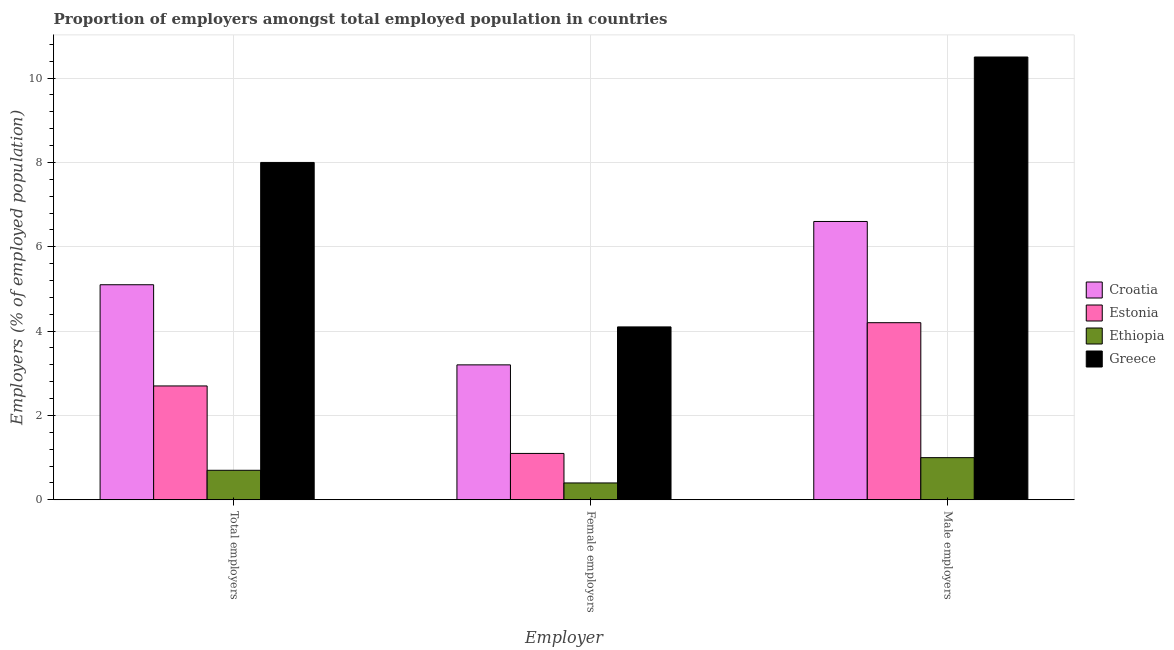How many bars are there on the 1st tick from the right?
Your answer should be very brief. 4. What is the label of the 2nd group of bars from the left?
Make the answer very short. Female employers. What is the percentage of female employers in Ethiopia?
Give a very brief answer. 0.4. Across all countries, what is the maximum percentage of female employers?
Your answer should be compact. 4.1. In which country was the percentage of male employers maximum?
Your response must be concise. Greece. In which country was the percentage of male employers minimum?
Offer a terse response. Ethiopia. What is the total percentage of total employers in the graph?
Your answer should be very brief. 16.5. What is the difference between the percentage of total employers in Greece and that in Estonia?
Make the answer very short. 5.3. What is the difference between the percentage of female employers in Estonia and the percentage of total employers in Greece?
Your response must be concise. -6.9. What is the average percentage of total employers per country?
Offer a very short reply. 4.12. What is the difference between the percentage of female employers and percentage of male employers in Estonia?
Give a very brief answer. -3.1. What is the ratio of the percentage of male employers in Croatia to that in Greece?
Provide a short and direct response. 0.63. Is the percentage of total employers in Greece less than that in Estonia?
Ensure brevity in your answer.  No. What is the difference between the highest and the second highest percentage of female employers?
Keep it short and to the point. 0.9. What is the difference between the highest and the lowest percentage of total employers?
Offer a very short reply. 7.3. In how many countries, is the percentage of male employers greater than the average percentage of male employers taken over all countries?
Your answer should be very brief. 2. What does the 3rd bar from the left in Female employers represents?
Your answer should be compact. Ethiopia. What does the 4th bar from the right in Male employers represents?
Offer a terse response. Croatia. Is it the case that in every country, the sum of the percentage of total employers and percentage of female employers is greater than the percentage of male employers?
Offer a terse response. No. What is the difference between two consecutive major ticks on the Y-axis?
Ensure brevity in your answer.  2. How are the legend labels stacked?
Your response must be concise. Vertical. What is the title of the graph?
Provide a succinct answer. Proportion of employers amongst total employed population in countries. Does "Ethiopia" appear as one of the legend labels in the graph?
Keep it short and to the point. Yes. What is the label or title of the X-axis?
Your response must be concise. Employer. What is the label or title of the Y-axis?
Make the answer very short. Employers (% of employed population). What is the Employers (% of employed population) in Croatia in Total employers?
Provide a short and direct response. 5.1. What is the Employers (% of employed population) of Estonia in Total employers?
Provide a short and direct response. 2.7. What is the Employers (% of employed population) of Ethiopia in Total employers?
Provide a short and direct response. 0.7. What is the Employers (% of employed population) in Croatia in Female employers?
Provide a short and direct response. 3.2. What is the Employers (% of employed population) in Estonia in Female employers?
Keep it short and to the point. 1.1. What is the Employers (% of employed population) in Ethiopia in Female employers?
Give a very brief answer. 0.4. What is the Employers (% of employed population) in Greece in Female employers?
Keep it short and to the point. 4.1. What is the Employers (% of employed population) of Croatia in Male employers?
Your response must be concise. 6.6. What is the Employers (% of employed population) in Estonia in Male employers?
Give a very brief answer. 4.2. What is the Employers (% of employed population) in Ethiopia in Male employers?
Make the answer very short. 1. What is the Employers (% of employed population) in Greece in Male employers?
Offer a very short reply. 10.5. Across all Employer, what is the maximum Employers (% of employed population) of Croatia?
Offer a terse response. 6.6. Across all Employer, what is the maximum Employers (% of employed population) of Estonia?
Your answer should be compact. 4.2. Across all Employer, what is the minimum Employers (% of employed population) in Croatia?
Give a very brief answer. 3.2. Across all Employer, what is the minimum Employers (% of employed population) of Estonia?
Provide a short and direct response. 1.1. Across all Employer, what is the minimum Employers (% of employed population) of Ethiopia?
Give a very brief answer. 0.4. Across all Employer, what is the minimum Employers (% of employed population) in Greece?
Provide a short and direct response. 4.1. What is the total Employers (% of employed population) of Croatia in the graph?
Make the answer very short. 14.9. What is the total Employers (% of employed population) in Estonia in the graph?
Provide a succinct answer. 8. What is the total Employers (% of employed population) of Greece in the graph?
Keep it short and to the point. 22.6. What is the difference between the Employers (% of employed population) in Croatia in Total employers and that in Female employers?
Keep it short and to the point. 1.9. What is the difference between the Employers (% of employed population) in Estonia in Total employers and that in Female employers?
Provide a succinct answer. 1.6. What is the difference between the Employers (% of employed population) in Ethiopia in Total employers and that in Female employers?
Ensure brevity in your answer.  0.3. What is the difference between the Employers (% of employed population) of Greece in Total employers and that in Female employers?
Offer a terse response. 3.9. What is the difference between the Employers (% of employed population) in Croatia in Total employers and that in Male employers?
Ensure brevity in your answer.  -1.5. What is the difference between the Employers (% of employed population) in Estonia in Total employers and that in Male employers?
Provide a succinct answer. -1.5. What is the difference between the Employers (% of employed population) in Ethiopia in Total employers and that in Male employers?
Provide a short and direct response. -0.3. What is the difference between the Employers (% of employed population) in Greece in Total employers and that in Male employers?
Provide a short and direct response. -2.5. What is the difference between the Employers (% of employed population) in Croatia in Female employers and that in Male employers?
Offer a very short reply. -3.4. What is the difference between the Employers (% of employed population) of Estonia in Female employers and that in Male employers?
Give a very brief answer. -3.1. What is the difference between the Employers (% of employed population) in Ethiopia in Female employers and that in Male employers?
Your response must be concise. -0.6. What is the difference between the Employers (% of employed population) in Greece in Female employers and that in Male employers?
Keep it short and to the point. -6.4. What is the difference between the Employers (% of employed population) of Estonia in Total employers and the Employers (% of employed population) of Ethiopia in Female employers?
Provide a succinct answer. 2.3. What is the difference between the Employers (% of employed population) of Estonia in Total employers and the Employers (% of employed population) of Greece in Female employers?
Your response must be concise. -1.4. What is the difference between the Employers (% of employed population) in Ethiopia in Total employers and the Employers (% of employed population) in Greece in Female employers?
Provide a short and direct response. -3.4. What is the difference between the Employers (% of employed population) of Croatia in Total employers and the Employers (% of employed population) of Ethiopia in Male employers?
Your answer should be very brief. 4.1. What is the difference between the Employers (% of employed population) in Croatia in Total employers and the Employers (% of employed population) in Greece in Male employers?
Offer a very short reply. -5.4. What is the difference between the Employers (% of employed population) in Estonia in Total employers and the Employers (% of employed population) in Greece in Male employers?
Offer a very short reply. -7.8. What is the difference between the Employers (% of employed population) of Croatia in Female employers and the Employers (% of employed population) of Estonia in Male employers?
Ensure brevity in your answer.  -1. What is the difference between the Employers (% of employed population) of Estonia in Female employers and the Employers (% of employed population) of Greece in Male employers?
Offer a terse response. -9.4. What is the average Employers (% of employed population) in Croatia per Employer?
Provide a succinct answer. 4.97. What is the average Employers (% of employed population) of Estonia per Employer?
Your response must be concise. 2.67. What is the average Employers (% of employed population) in Greece per Employer?
Provide a succinct answer. 7.53. What is the difference between the Employers (% of employed population) of Croatia and Employers (% of employed population) of Greece in Total employers?
Your response must be concise. -2.9. What is the difference between the Employers (% of employed population) in Estonia and Employers (% of employed population) in Ethiopia in Total employers?
Offer a terse response. 2. What is the difference between the Employers (% of employed population) of Estonia and Employers (% of employed population) of Greece in Total employers?
Keep it short and to the point. -5.3. What is the difference between the Employers (% of employed population) of Ethiopia and Employers (% of employed population) of Greece in Total employers?
Give a very brief answer. -7.3. What is the difference between the Employers (% of employed population) of Croatia and Employers (% of employed population) of Estonia in Female employers?
Offer a terse response. 2.1. What is the difference between the Employers (% of employed population) in Croatia and Employers (% of employed population) in Ethiopia in Male employers?
Provide a short and direct response. 5.6. What is the difference between the Employers (% of employed population) in Estonia and Employers (% of employed population) in Ethiopia in Male employers?
Make the answer very short. 3.2. What is the difference between the Employers (% of employed population) of Estonia and Employers (% of employed population) of Greece in Male employers?
Your answer should be very brief. -6.3. What is the ratio of the Employers (% of employed population) in Croatia in Total employers to that in Female employers?
Provide a short and direct response. 1.59. What is the ratio of the Employers (% of employed population) in Estonia in Total employers to that in Female employers?
Your response must be concise. 2.45. What is the ratio of the Employers (% of employed population) in Ethiopia in Total employers to that in Female employers?
Provide a short and direct response. 1.75. What is the ratio of the Employers (% of employed population) in Greece in Total employers to that in Female employers?
Keep it short and to the point. 1.95. What is the ratio of the Employers (% of employed population) in Croatia in Total employers to that in Male employers?
Offer a very short reply. 0.77. What is the ratio of the Employers (% of employed population) of Estonia in Total employers to that in Male employers?
Ensure brevity in your answer.  0.64. What is the ratio of the Employers (% of employed population) in Greece in Total employers to that in Male employers?
Your answer should be compact. 0.76. What is the ratio of the Employers (% of employed population) of Croatia in Female employers to that in Male employers?
Provide a short and direct response. 0.48. What is the ratio of the Employers (% of employed population) of Estonia in Female employers to that in Male employers?
Your answer should be compact. 0.26. What is the ratio of the Employers (% of employed population) of Ethiopia in Female employers to that in Male employers?
Offer a terse response. 0.4. What is the ratio of the Employers (% of employed population) in Greece in Female employers to that in Male employers?
Offer a very short reply. 0.39. What is the difference between the highest and the second highest Employers (% of employed population) of Ethiopia?
Keep it short and to the point. 0.3. 